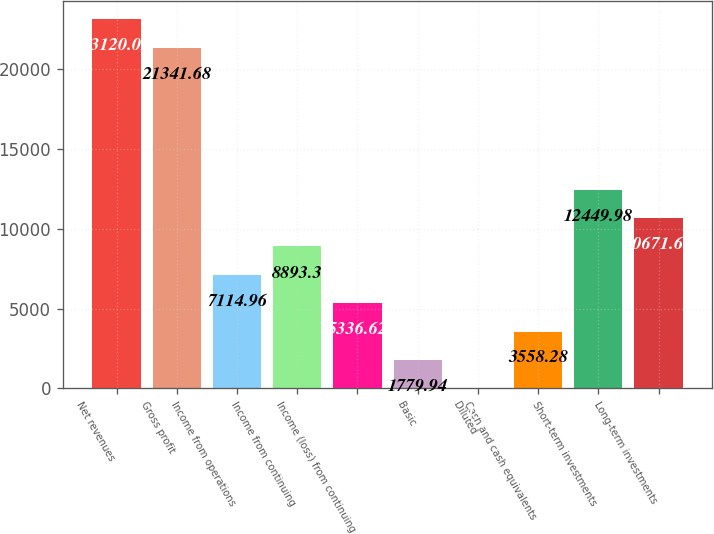Convert chart. <chart><loc_0><loc_0><loc_500><loc_500><bar_chart><fcel>Net revenues<fcel>Gross profit<fcel>Income from operations<fcel>Income from continuing<fcel>Income (loss) from continuing<fcel>Basic<fcel>Diluted<fcel>Cash and cash equivalents<fcel>Short-term investments<fcel>Long-term investments<nl><fcel>23120<fcel>21341.7<fcel>7114.96<fcel>8893.3<fcel>5336.62<fcel>1779.94<fcel>1.6<fcel>3558.28<fcel>12450<fcel>10671.6<nl></chart> 